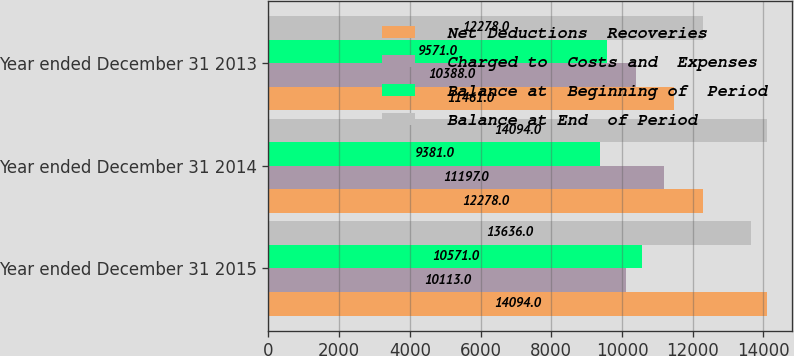<chart> <loc_0><loc_0><loc_500><loc_500><stacked_bar_chart><ecel><fcel>Year ended December 31 2015<fcel>Year ended December 31 2014<fcel>Year ended December 31 2013<nl><fcel>Net Deductions  Recoveries<fcel>14094<fcel>12278<fcel>11461<nl><fcel>Charged to  Costs and  Expenses<fcel>10113<fcel>11197<fcel>10388<nl><fcel>Balance at  Beginning of  Period<fcel>10571<fcel>9381<fcel>9571<nl><fcel>Balance at End  of Period<fcel>13636<fcel>14094<fcel>12278<nl></chart> 